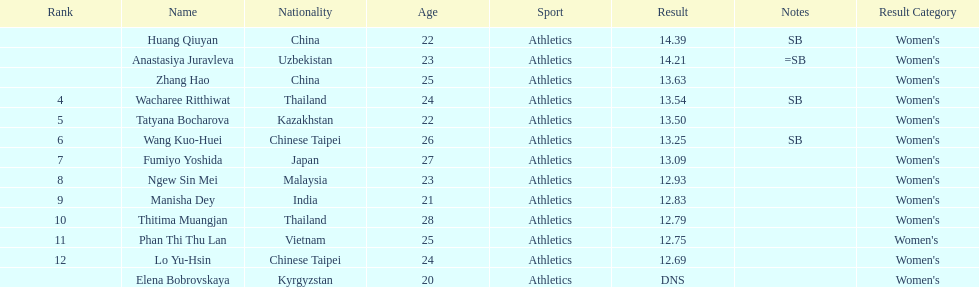How long was manisha dey's jump? 12.83. 